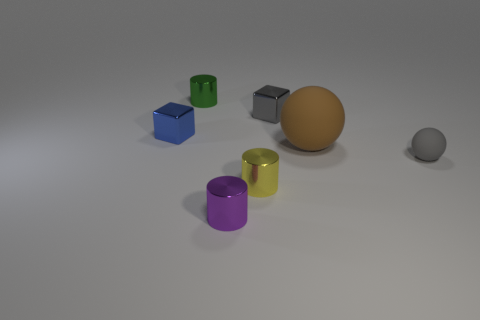Add 2 green shiny cylinders. How many objects exist? 9 Subtract all blocks. How many objects are left? 5 Subtract 1 gray cubes. How many objects are left? 6 Subtract all shiny spheres. Subtract all tiny yellow metallic cylinders. How many objects are left? 6 Add 4 metal cylinders. How many metal cylinders are left? 7 Add 4 balls. How many balls exist? 6 